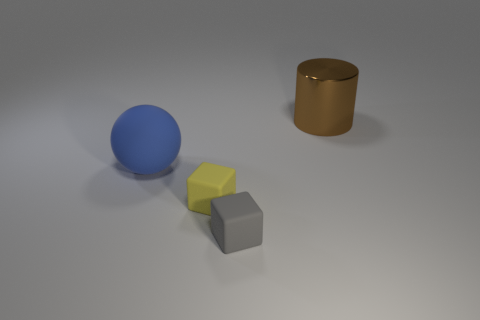Add 1 large brown rubber cylinders. How many objects exist? 5 Subtract all balls. How many objects are left? 3 Subtract all gray blocks. How many blocks are left? 1 Subtract 0 red blocks. How many objects are left? 4 Subtract 1 spheres. How many spheres are left? 0 Subtract all blue cylinders. Subtract all green spheres. How many cylinders are left? 1 Subtract all gray spheres. How many purple cylinders are left? 0 Subtract all yellow cylinders. Subtract all small gray blocks. How many objects are left? 3 Add 2 big brown metallic cylinders. How many big brown metallic cylinders are left? 3 Add 4 yellow blocks. How many yellow blocks exist? 5 